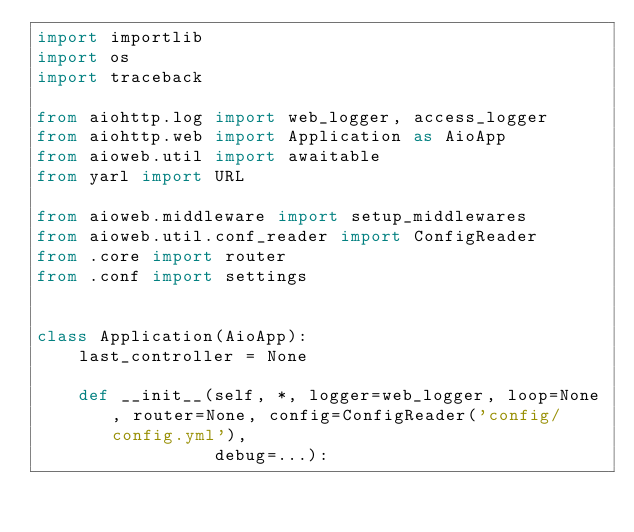<code> <loc_0><loc_0><loc_500><loc_500><_Python_>import importlib
import os
import traceback

from aiohttp.log import web_logger, access_logger
from aiohttp.web import Application as AioApp
from aioweb.util import awaitable
from yarl import URL

from aioweb.middleware import setup_middlewares
from aioweb.util.conf_reader import ConfigReader
from .core import router
from .conf import settings


class Application(AioApp):
    last_controller = None

    def __init__(self, *, logger=web_logger, loop=None, router=None, config=ConfigReader('config/config.yml'),
                 debug=...):</code> 